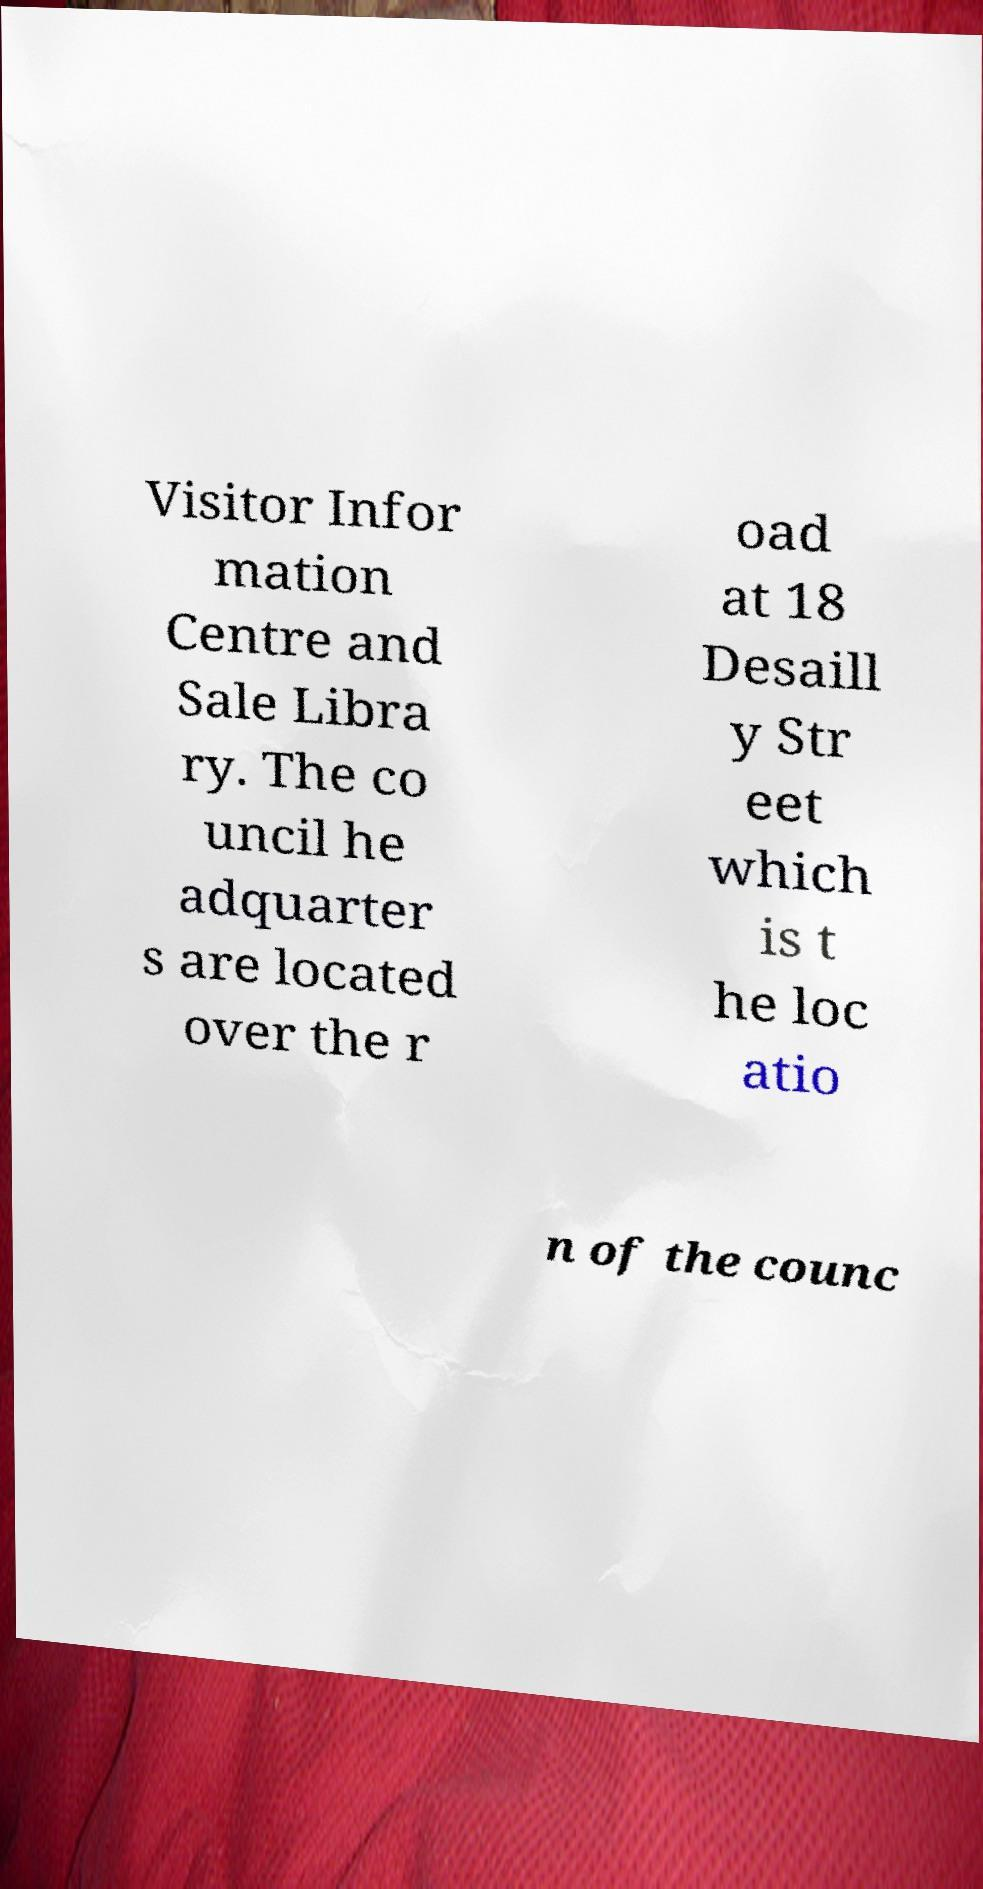I need the written content from this picture converted into text. Can you do that? Visitor Infor mation Centre and Sale Libra ry. The co uncil he adquarter s are located over the r oad at 18 Desaill y Str eet which is t he loc atio n of the counc 